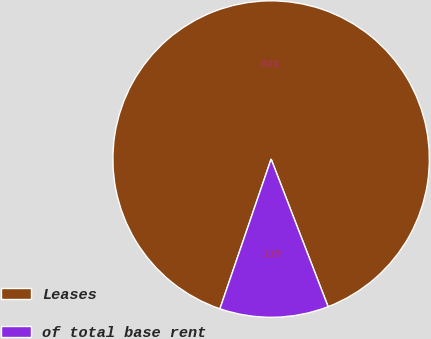Convert chart. <chart><loc_0><loc_0><loc_500><loc_500><pie_chart><fcel>Leases<fcel>of total base rent<nl><fcel>88.89%<fcel>11.11%<nl></chart> 